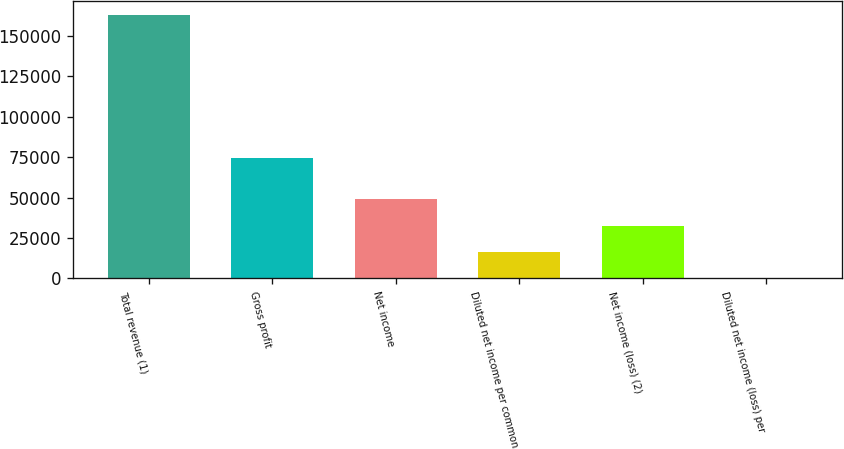Convert chart to OTSL. <chart><loc_0><loc_0><loc_500><loc_500><bar_chart><fcel>Total revenue (1)<fcel>Gross profit<fcel>Net income<fcel>Diluted net income per common<fcel>Net income (loss) (2)<fcel>Diluted net income (loss) per<nl><fcel>163212<fcel>74355<fcel>48963.7<fcel>16321.3<fcel>32642.5<fcel>0.12<nl></chart> 